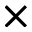Convert formula to latex. <formula><loc_0><loc_0><loc_500><loc_500>\times</formula> 